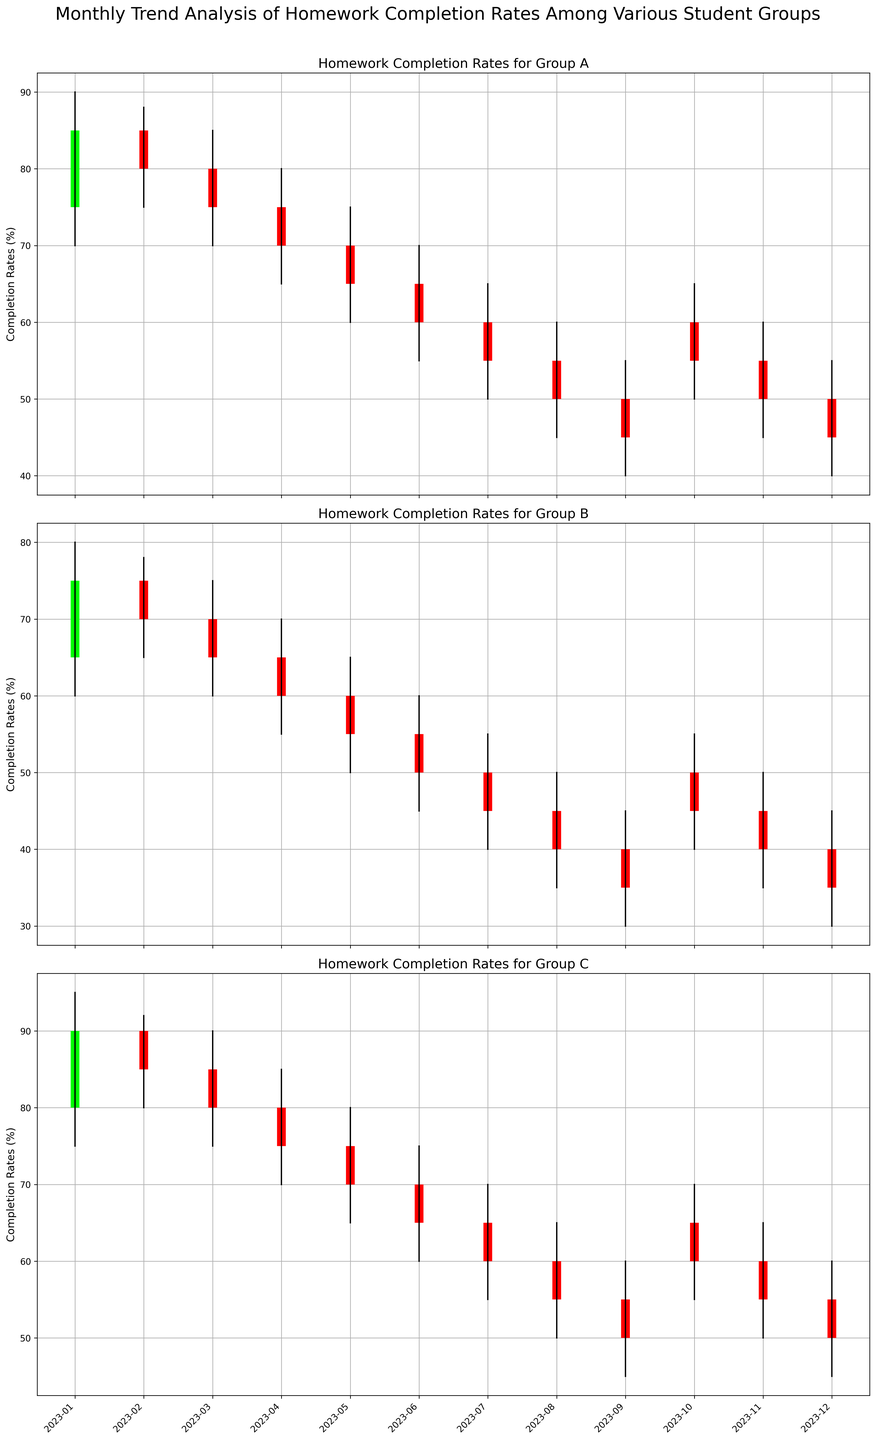What is the general trend in homework completion rates for Group A throughout the year 2023? The plot for Group A shows a declining trend in the closing values from January to December. Initially, the completion rate is high, but it gradually declines until it improves slightly in October and then drops again.
Answer: Declining Which month had the highest homework completion rate for Group C? From the figure, we see that in January, Group C has the highest close value at 90.
Answer: January In which month did Group B experience the largest drop in homework completion rates? From February to March, Group B's close value drops from 70 to 65. However, the largest drop is from January (75) to February (70).
Answer: January to February How does the completion rate for Group A in April compare to Group C in the same month? In April, Group A's close value is 70 while Group C's close value is 75. Group C has a higher completion rate.
Answer: Group C is higher Compare the trends of completion rates for Group B and Group C in the first half of 2023. Group B shows a decreasing trend every month. On the other hand, Group C starts higher and then also declines but at a slower pace.
Answer: Group B decreases faster What is the difference between the highest high and lowest low for Group B during the year 2023? Group B's highest high is 80 (January) and lowest low is 30 (September and December). The difference is 80 - 30 = 50.
Answer: 50 Among all groups in 2023, which group and month had the largest range in homework completion rates? For each group, calculate the difference (High - Low). Group C in January has the largest range: 95 - 75 = 20.
Answer: Group C in January What is the average closing rate for Group C over the entire year? Sum the closing rates for Group C [90, 85, 80, 75, 70, 65, 60, 55, 50, 60, 55, 50] which equals 795. Divide by 12 months: 795 / 12 ≈ 66.25%.
Answer: 66.25% Which group showed the most consistent homework completion rates, based on the smallest variance in closing values? Calculate variance for closing rates in each group. Group B has the closing rates: [75, 70, 65, 60, 55, 50, 45, 40, 35, 45, 40, 35]. Variance of these values compared to others shows Group B is most consistent.
Answer: Group B 